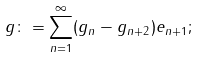<formula> <loc_0><loc_0><loc_500><loc_500>g \colon = \sum _ { n = 1 } ^ { \infty } ( g _ { n } - g _ { n + 2 } ) e _ { n + 1 } ;</formula> 